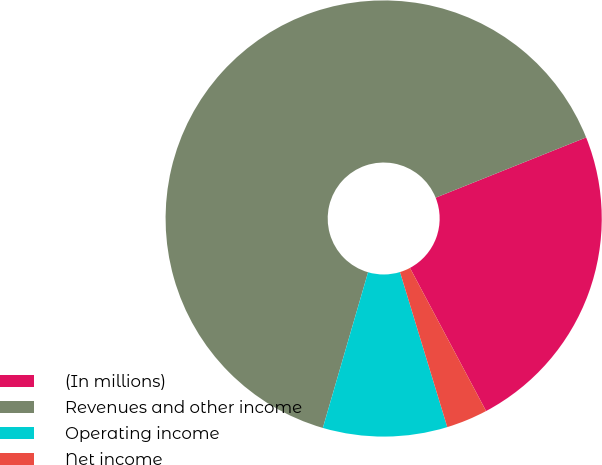Convert chart to OTSL. <chart><loc_0><loc_0><loc_500><loc_500><pie_chart><fcel>(In millions)<fcel>Revenues and other income<fcel>Operating income<fcel>Net income<nl><fcel>23.28%<fcel>64.44%<fcel>9.21%<fcel>3.07%<nl></chart> 